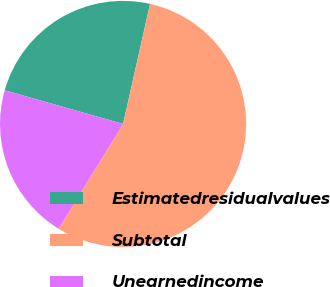<chart> <loc_0><loc_0><loc_500><loc_500><pie_chart><fcel>Estimatedresidualvalues<fcel>Subtotal<fcel>Unearnedincome<nl><fcel>24.11%<fcel>55.25%<fcel>20.65%<nl></chart> 